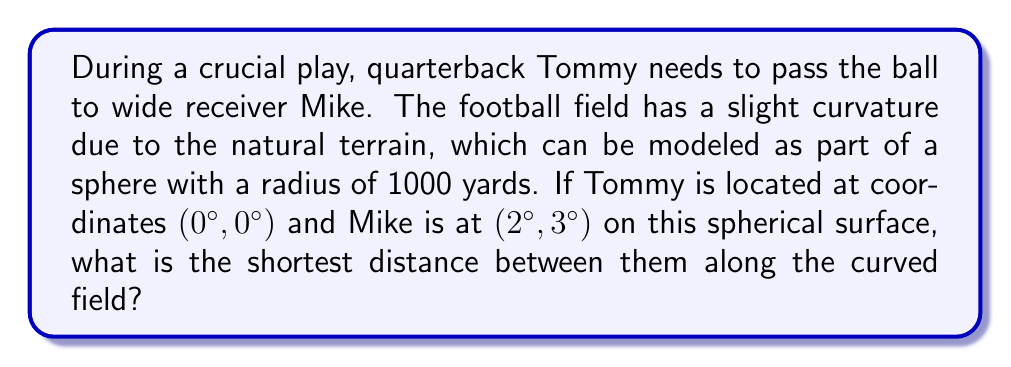Provide a solution to this math problem. To solve this problem, we need to use the concept of great circle distance on a sphere. This is the shortest path between two points on a curved surface, which is analogous to a straight line on a flat plane.

Step 1: Convert the given angle measurements to radians.
$$\theta_1 = 0°, \phi_1 = 0°$$
$$\theta_2 = 2° \cdot \frac{\pi}{180°} = \frac{\pi}{90} \text{ radians}$$
$$\phi_2 = 3° \cdot \frac{\pi}{180°} = \frac{\pi}{60} \text{ radians}$$

Step 2: Use the spherical law of cosines to find the central angle $\Delta\sigma$ between the two points.
$$\cos(\Delta\sigma) = \sin(\theta_1)\sin(\theta_2) + \cos(\theta_1)\cos(\theta_2)\cos(\phi_2 - \phi_1)$$
$$\cos(\Delta\sigma) = \sin(0)\sin(\frac{\pi}{90}) + \cos(0)\cos(\frac{\pi}{90})\cos(\frac{\pi}{60} - 0)$$
$$\cos(\Delta\sigma) = 0 + \cos(\frac{\pi}{90})\cos(\frac{\pi}{60})$$
$$\cos(\Delta\sigma) = 0.9998477$$

Step 3: Calculate $\Delta\sigma$ by taking the inverse cosine.
$$\Delta\sigma = \arccos(0.9998477) = 0.0174533 \text{ radians}$$

Step 4: Calculate the shortest distance $d$ along the curved field using the formula:
$$d = R \cdot \Delta\sigma$$
Where $R$ is the radius of the sphere (1000 yards in this case).

$$d = 1000 \cdot 0.0174533 = 17.4533 \text{ yards}$$

Therefore, the shortest distance between Tommy and Mike along the curved field is approximately 17.4533 yards.
Answer: 17.4533 yards 